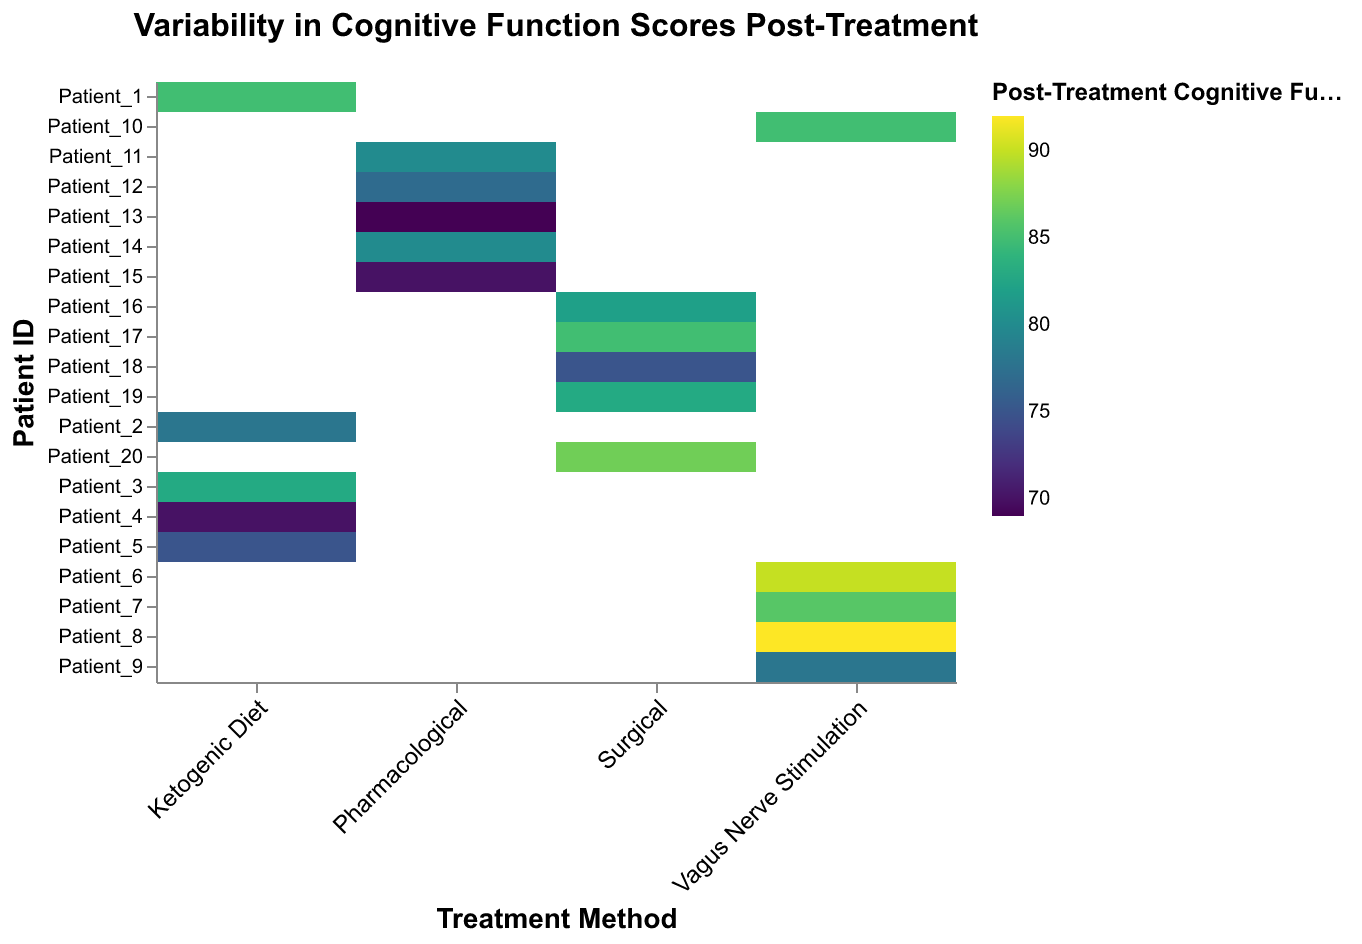What is the title of the figure? The title of the figure is located at the top and states the main subject of the heatmap.
Answer: Variability in Cognitive Function Scores Post-Treatment Which treatment method shows the highest post-treatment cognitive function score for any patient? To determine this, look for the highest color intensity which represents the highest post-treatment cognitive function score, then identify the corresponding treatment method.
Answer: Vagus Nerve Stimulation Which patient under the ketogenic diet has the lowest pre-treatment cognitive function score? Locate the column for the "Ketogenic Diet" and identify the patient with the lowest pre-treatment cognitive function value.
Answer: Patient_4 How many patients received surgical treatment? Count the number of unique patient IDs listed under the "Surgical" column.
Answer: 5 Which treatment method had the most consistent improvement in cognitive function scores? Find the treatment method with the smallest range (difference between the highest and lowest) in post-treatment cognitive function scores.
Answer: Vagus Nerve Stimulation What is the average post-treatment cognitive function score for patients treated with a ketogenic diet? Add up all the post-treatment cognitive function scores for patients under the ketogenic diet and divide by the number of patients.
Answer: 78.2 Compare the highest post-treatment cognitive function score in the pharmacological group with the surgical group. Which is higher? Identify the highest post-treatment cognitive function score within each treatment method and compare them to see which is higher.
Answer: Surgical What is the difference in post-treatment cognitive function score between Patient_3 on the ketogenic diet and Patient_18 who underwent surgery? Subtract the post-treatment cognitive function score of Patient_18 from that of Patient_3 to find the difference.
Answer: 8 Which treatment method appears to have the highest variation in post-treatment cognitive function scores? Observe the spread or range of colors in each treatment method column and find the one with the widest range.
Answer: Ketogenic Diet How many patients had a pre-treatment cognitive function score below 60? Identify the number of patients across all treatment methods with pre-treatment cognitive function scores less than 60.
Answer: 2 